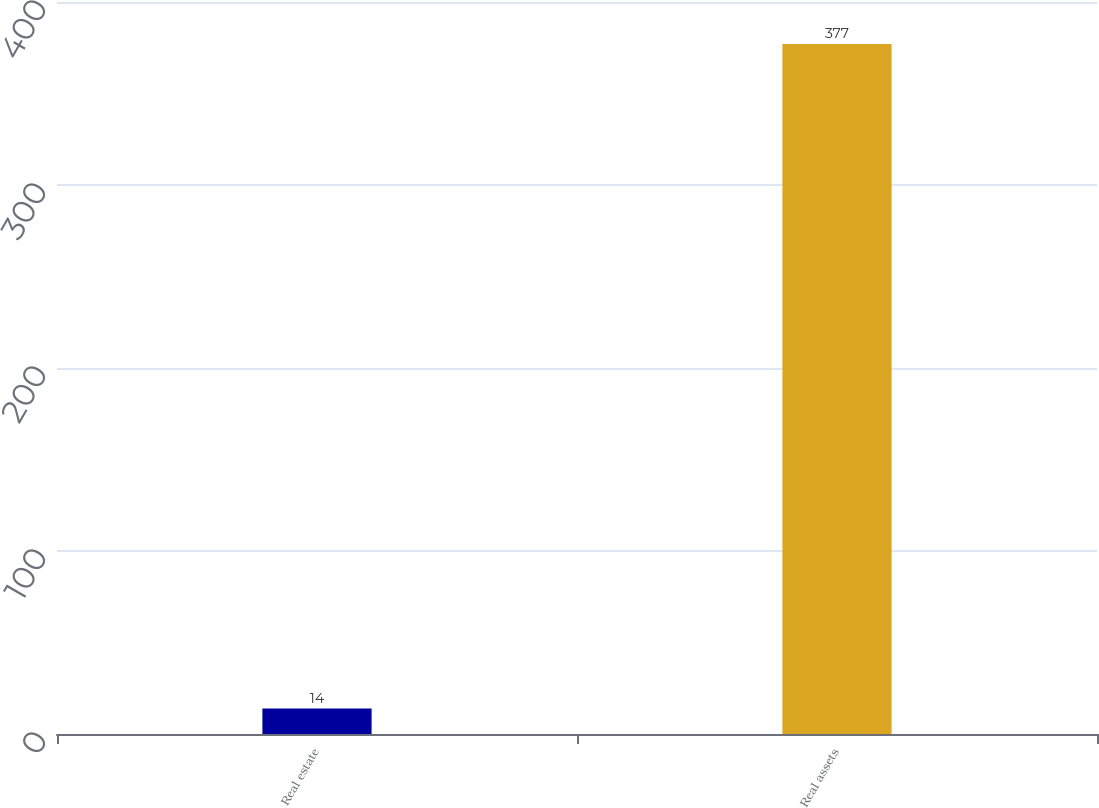<chart> <loc_0><loc_0><loc_500><loc_500><bar_chart><fcel>Real estate<fcel>Real assets<nl><fcel>14<fcel>377<nl></chart> 